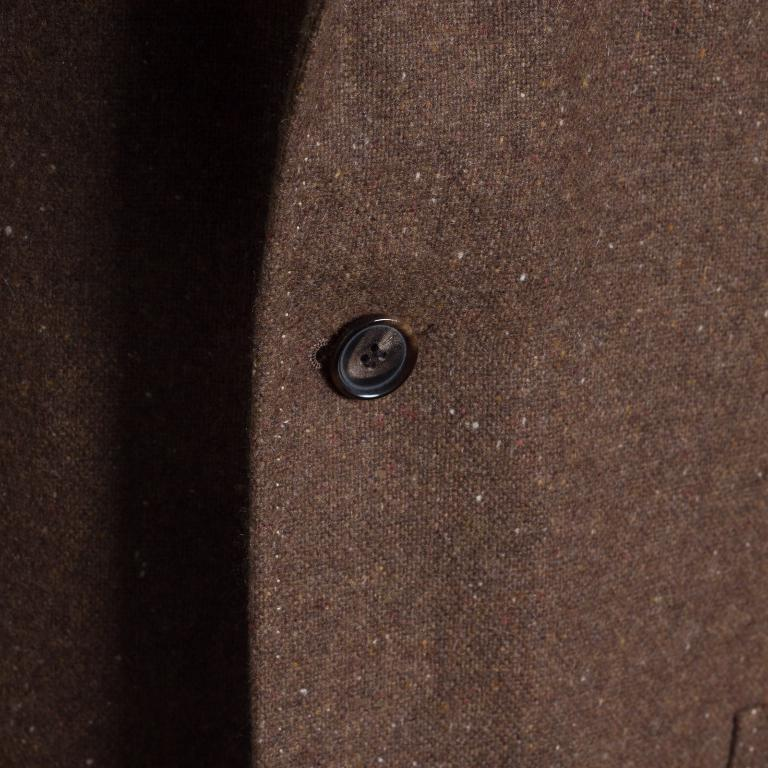What object is the main focus of the image? The main focus of the image is a button. Where is the button located? The button is on a piece of cloth. What type of treatment is being administered to the button in the image? There is no treatment being administered to the button in the image; it is simply a button on a piece of cloth. 